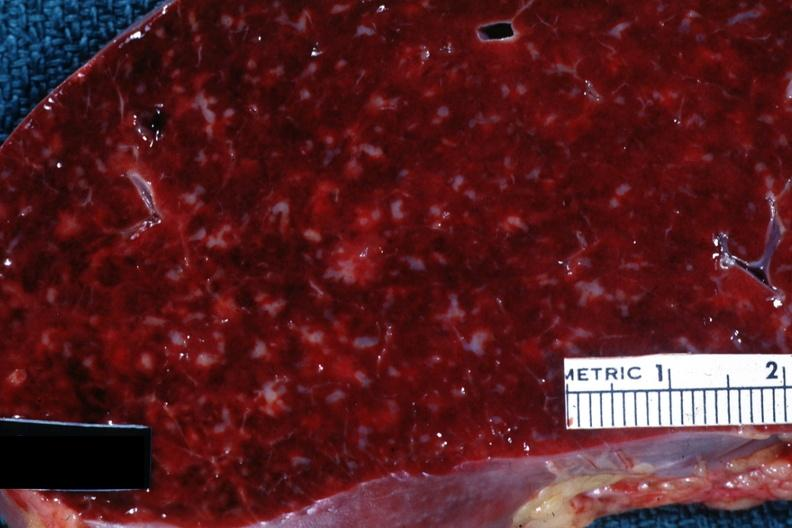s chronic lymphocytic leukemia present?
Answer the question using a single word or phrase. Yes 